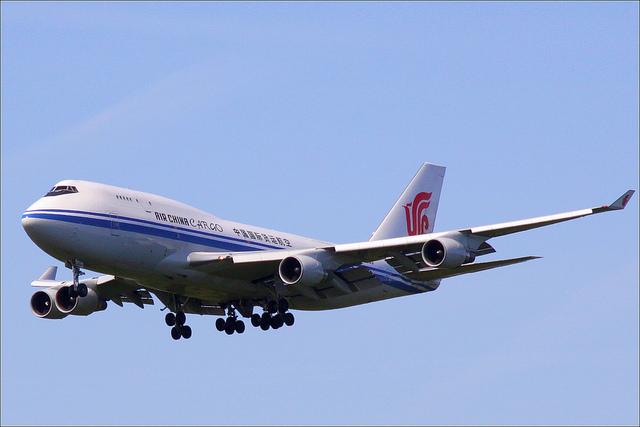Might the airplane be preparing for a landing?
Quick response, please. Yes. Is this Air China plane?
Give a very brief answer. Yes. How many planes are shown?
Answer briefly. 1. How many wheels are visible?
Be succinct. 12. 